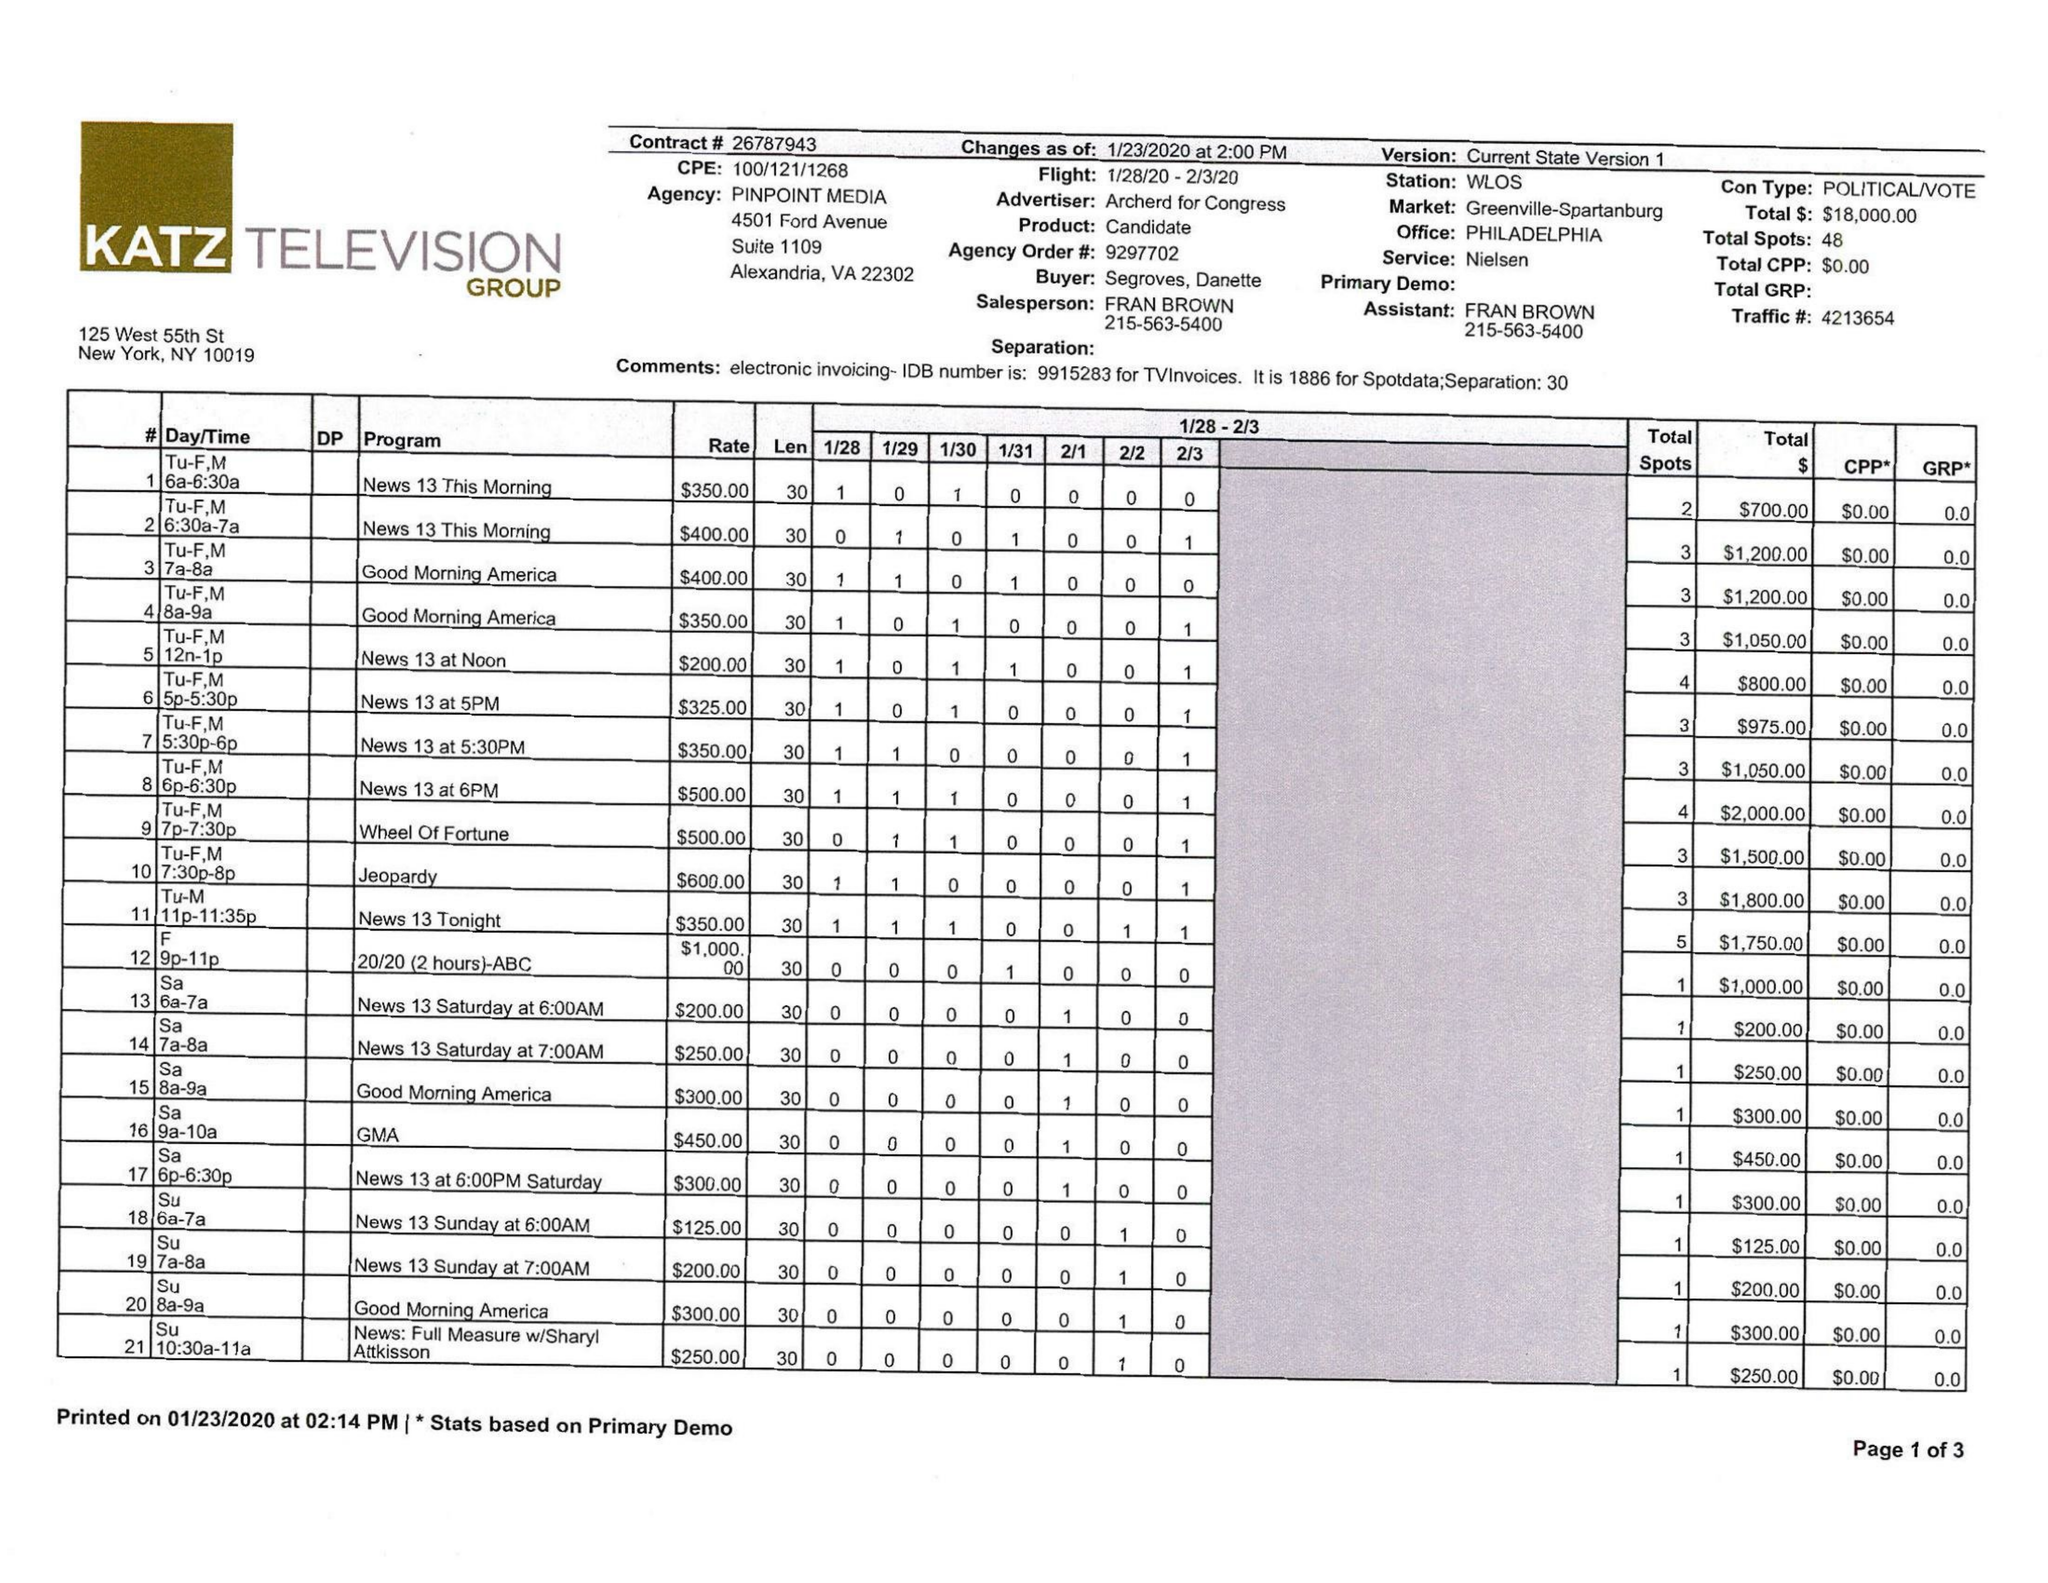What is the value for the advertiser?
Answer the question using a single word or phrase. ARCHERD FOR CONGRESS 